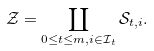<formula> <loc_0><loc_0><loc_500><loc_500>\mathcal { Z } = \coprod _ { 0 \leq t \leq m , i \in \mathcal { I } _ { t } } \mathcal { S } _ { t , i } .</formula> 